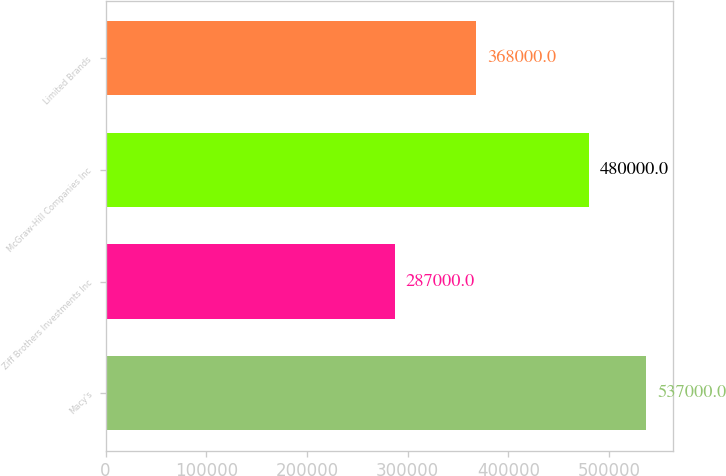Convert chart to OTSL. <chart><loc_0><loc_0><loc_500><loc_500><bar_chart><fcel>Macy's<fcel>Ziff Brothers Investments Inc<fcel>McGraw-Hill Companies Inc<fcel>Limited Brands<nl><fcel>537000<fcel>287000<fcel>480000<fcel>368000<nl></chart> 